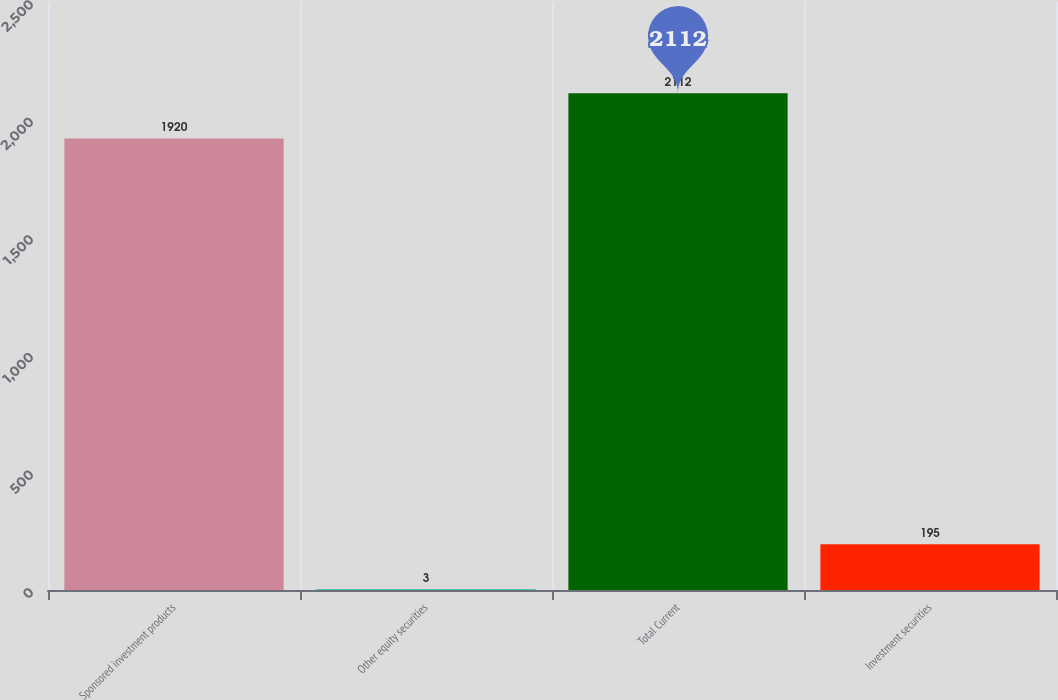Convert chart. <chart><loc_0><loc_0><loc_500><loc_500><bar_chart><fcel>Sponsored investment products<fcel>Other equity securities<fcel>Total Current<fcel>Investment securities<nl><fcel>1920<fcel>3<fcel>2112<fcel>195<nl></chart> 